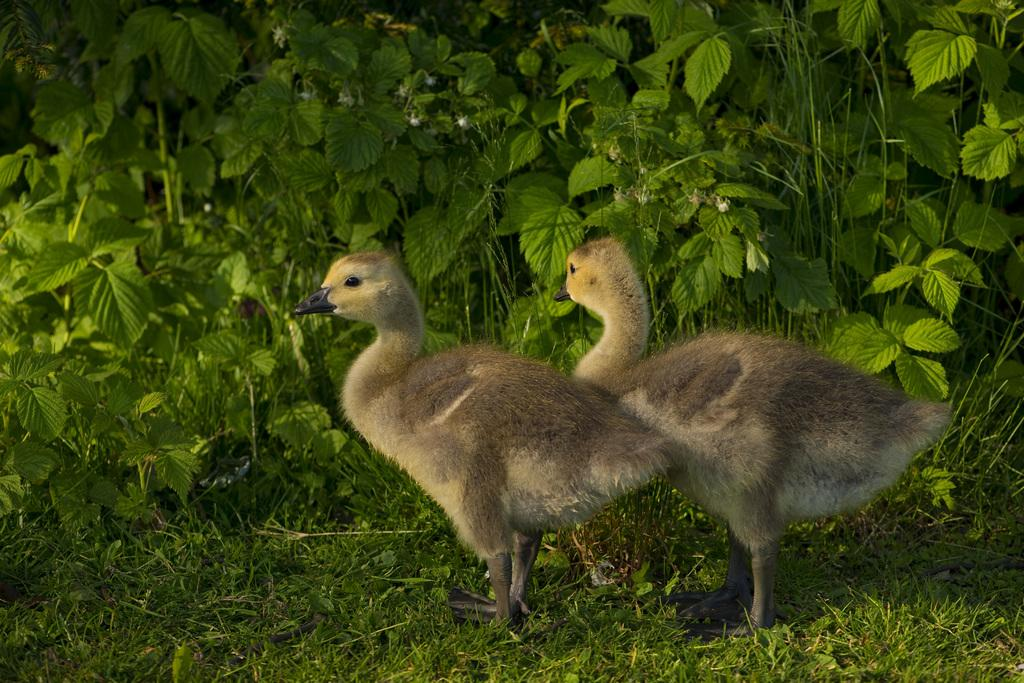What animals are in the center of the image? There are two birds in the center of the image. What is the surface the birds are standing on? The birds are on a glass land. What can be seen in the background of the image? There are plants in the background of the image. What type of juice is being served by the secretary on the hill in the image? There is no juice, secretary, or hill present in the image; it features two birds on a glass land with plants in the background. 